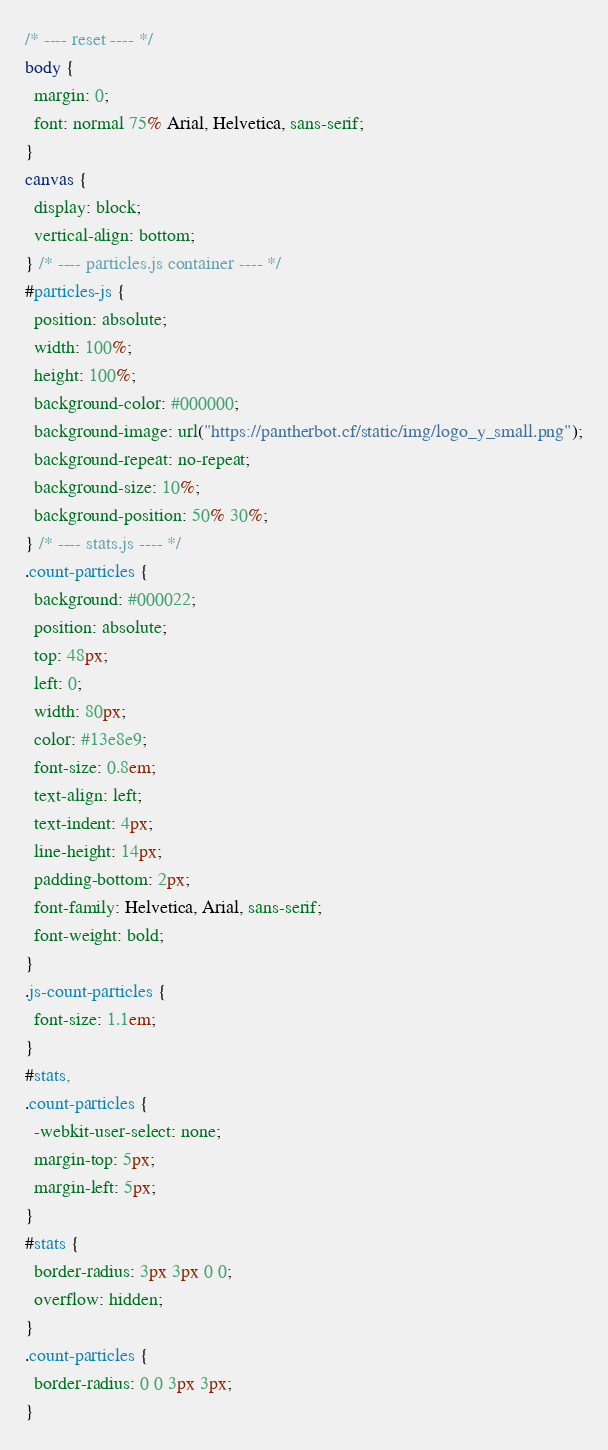<code> <loc_0><loc_0><loc_500><loc_500><_CSS_>/* ---- reset ---- */
body {
  margin: 0;
  font: normal 75% Arial, Helvetica, sans-serif;
}
canvas {
  display: block;
  vertical-align: bottom;
} /* ---- particles.js container ---- */
#particles-js {
  position: absolute;
  width: 100%;
  height: 100%;
  background-color: #000000;
  background-image: url("https://pantherbot.cf/static/img/logo_y_small.png");
  background-repeat: no-repeat;
  background-size: 10%;
  background-position: 50% 30%;
} /* ---- stats.js ---- */
.count-particles {
  background: #000022;
  position: absolute;
  top: 48px;
  left: 0;
  width: 80px;
  color: #13e8e9;
  font-size: 0.8em;
  text-align: left;
  text-indent: 4px;
  line-height: 14px;
  padding-bottom: 2px;
  font-family: Helvetica, Arial, sans-serif;
  font-weight: bold;
}
.js-count-particles {
  font-size: 1.1em;
}
#stats,
.count-particles {
  -webkit-user-select: none;
  margin-top: 5px;
  margin-left: 5px;
}
#stats {
  border-radius: 3px 3px 0 0;
  overflow: hidden;
}
.count-particles {
  border-radius: 0 0 3px 3px;
}
</code> 